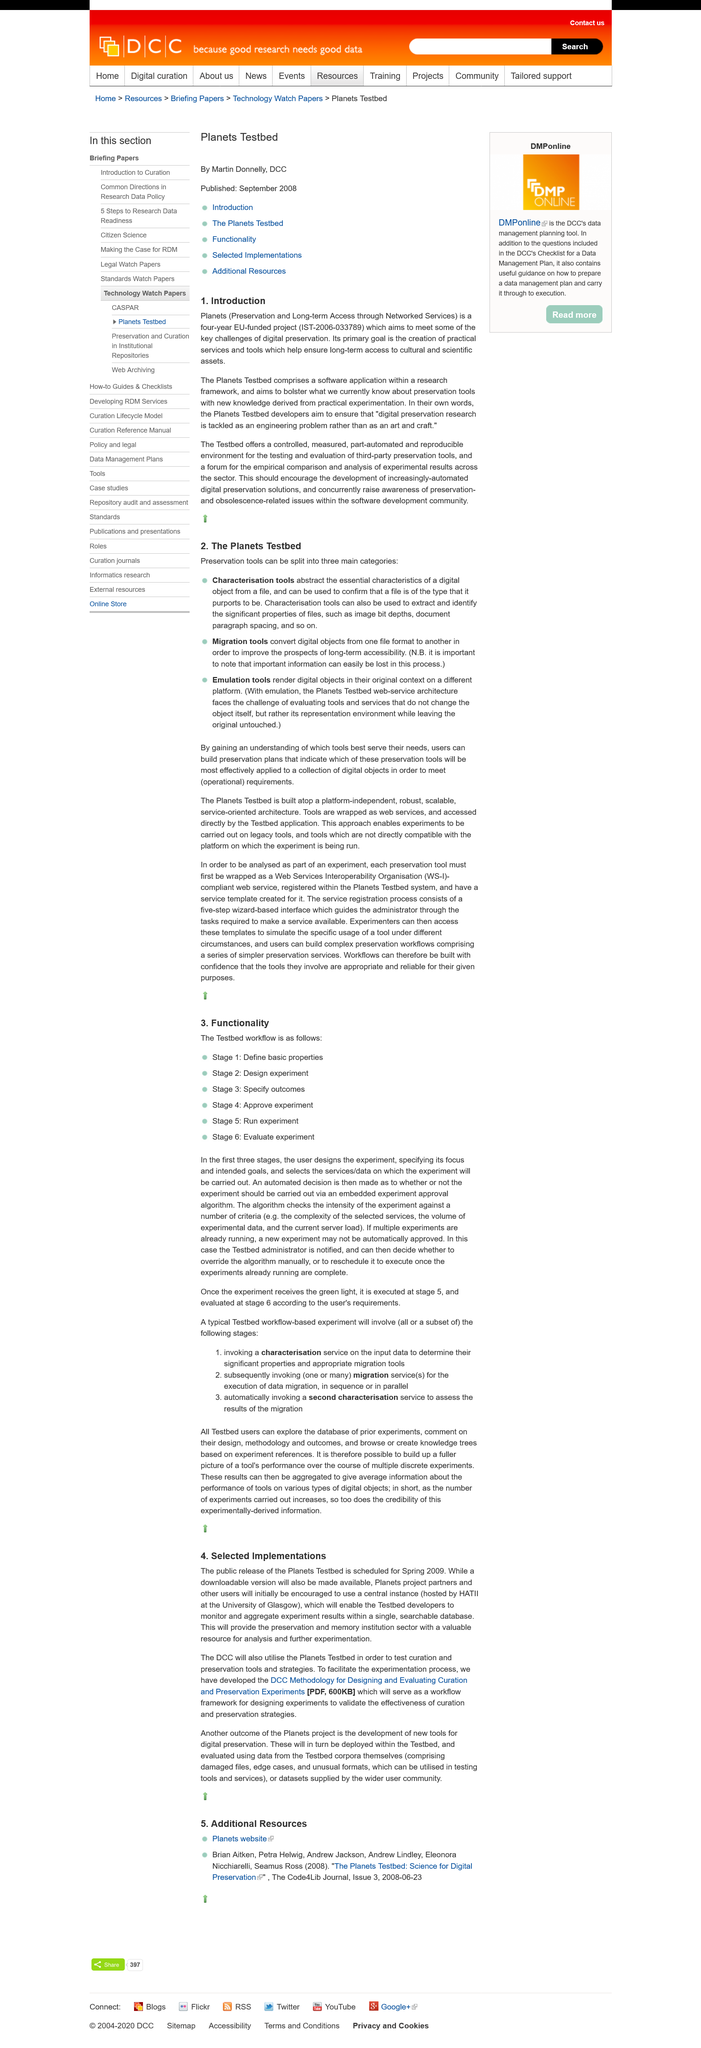Highlight a few significant elements in this photo. I declare that 'planets' stands for the acronym 'Preservation and Long-term Access through Networked Services'. This is the first subheading. The "planets" project was funded by the European Union. 